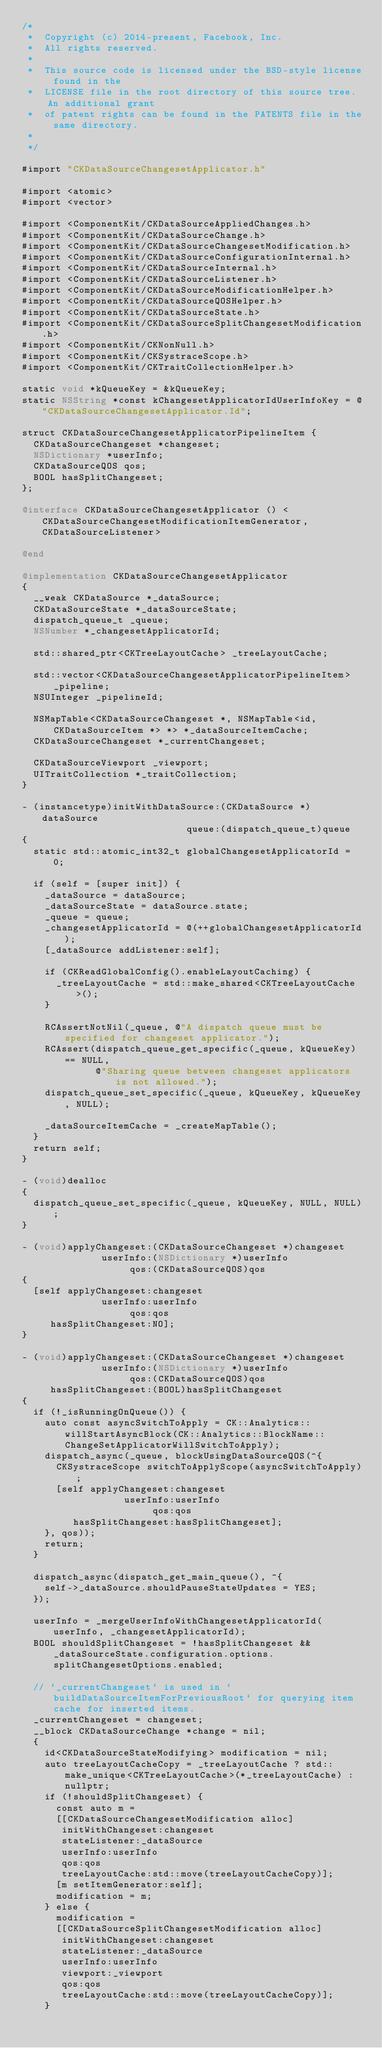Convert code to text. <code><loc_0><loc_0><loc_500><loc_500><_ObjectiveC_>/*
 *  Copyright (c) 2014-present, Facebook, Inc.
 *  All rights reserved.
 *
 *  This source code is licensed under the BSD-style license found in the
 *  LICENSE file in the root directory of this source tree. An additional grant
 *  of patent rights can be found in the PATENTS file in the same directory.
 *
 */

#import "CKDataSourceChangesetApplicator.h"

#import <atomic>
#import <vector>

#import <ComponentKit/CKDataSourceAppliedChanges.h>
#import <ComponentKit/CKDataSourceChange.h>
#import <ComponentKit/CKDataSourceChangesetModification.h>
#import <ComponentKit/CKDataSourceConfigurationInternal.h>
#import <ComponentKit/CKDataSourceInternal.h>
#import <ComponentKit/CKDataSourceListener.h>
#import <ComponentKit/CKDataSourceModificationHelper.h>
#import <ComponentKit/CKDataSourceQOSHelper.h>
#import <ComponentKit/CKDataSourceState.h>
#import <ComponentKit/CKDataSourceSplitChangesetModification.h>
#import <ComponentKit/CKNonNull.h>
#import <ComponentKit/CKSystraceScope.h>
#import <ComponentKit/CKTraitCollectionHelper.h>

static void *kQueueKey = &kQueueKey;
static NSString *const kChangesetApplicatorIdUserInfoKey = @"CKDataSourceChangesetApplicator.Id";

struct CKDataSourceChangesetApplicatorPipelineItem {
  CKDataSourceChangeset *changeset;
  NSDictionary *userInfo;
  CKDataSourceQOS qos;
  BOOL hasSplitChangeset;
};

@interface CKDataSourceChangesetApplicator () <CKDataSourceChangesetModificationItemGenerator, CKDataSourceListener>

@end

@implementation CKDataSourceChangesetApplicator
{
  __weak CKDataSource *_dataSource;
  CKDataSourceState *_dataSourceState;
  dispatch_queue_t _queue;
  NSNumber *_changesetApplicatorId;

  std::shared_ptr<CKTreeLayoutCache> _treeLayoutCache;

  std::vector<CKDataSourceChangesetApplicatorPipelineItem> _pipeline;
  NSUInteger _pipelineId;

  NSMapTable<CKDataSourceChangeset *, NSMapTable<id, CKDataSourceItem *> *> *_dataSourceItemCache;
  CKDataSourceChangeset *_currentChangeset;

  CKDataSourceViewport _viewport;
  UITraitCollection *_traitCollection;
}

- (instancetype)initWithDataSource:(CKDataSource *)dataSource
                             queue:(dispatch_queue_t)queue
{
  static std::atomic_int32_t globalChangesetApplicatorId = 0;

  if (self = [super init]) {
    _dataSource = dataSource;
    _dataSourceState = dataSource.state;
    _queue = queue;
    _changesetApplicatorId = @(++globalChangesetApplicatorId);
    [_dataSource addListener:self];

    if (CKReadGlobalConfig().enableLayoutCaching) {
      _treeLayoutCache = std::make_shared<CKTreeLayoutCache>();
    }

    RCAssertNotNil(_queue, @"A dispatch queue must be specified for changeset applicator.");
    RCAssert(dispatch_queue_get_specific(_queue, kQueueKey) == NULL,
             @"Sharing queue between changeset applicators is not allowed.");
    dispatch_queue_set_specific(_queue, kQueueKey, kQueueKey, NULL);

    _dataSourceItemCache = _createMapTable();
  }
  return self;
}

- (void)dealloc
{
  dispatch_queue_set_specific(_queue, kQueueKey, NULL, NULL);
}

- (void)applyChangeset:(CKDataSourceChangeset *)changeset
              userInfo:(NSDictionary *)userInfo
                   qos:(CKDataSourceQOS)qos
{
  [self applyChangeset:changeset
              userInfo:userInfo
                   qos:qos
     hasSplitChangeset:NO];
}

- (void)applyChangeset:(CKDataSourceChangeset *)changeset
              userInfo:(NSDictionary *)userInfo
                   qos:(CKDataSourceQOS)qos
     hasSplitChangeset:(BOOL)hasSplitChangeset
{
  if (!_isRunningOnQueue()) {
    auto const asyncSwitchToApply = CK::Analytics::willStartAsyncBlock(CK::Analytics::BlockName::ChangeSetApplicatorWillSwitchToApply);
    dispatch_async(_queue, blockUsingDataSourceQOS(^{
      CKSystraceScope switchToApplyScope(asyncSwitchToApply);
      [self applyChangeset:changeset
                  userInfo:userInfo
                       qos:qos
         hasSplitChangeset:hasSplitChangeset];
    }, qos));
    return;
  }

  dispatch_async(dispatch_get_main_queue(), ^{
    self->_dataSource.shouldPauseStateUpdates = YES;
  });

  userInfo = _mergeUserInfoWithChangesetApplicatorId(userInfo, _changesetApplicatorId);
  BOOL shouldSplitChangeset = !hasSplitChangeset && _dataSourceState.configuration.options.splitChangesetOptions.enabled;

  // `_currentChangeset` is used in `buildDataSourceItemForPreviousRoot` for querying item cache for inserted items.
  _currentChangeset = changeset;
  __block CKDataSourceChange *change = nil;
  {
    id<CKDataSourceStateModifying> modification = nil;
    auto treeLayoutCacheCopy = _treeLayoutCache ? std::make_unique<CKTreeLayoutCache>(*_treeLayoutCache) : nullptr;
    if (!shouldSplitChangeset) {
      const auto m =
      [[CKDataSourceChangesetModification alloc]
       initWithChangeset:changeset
       stateListener:_dataSource
       userInfo:userInfo
       qos:qos
       treeLayoutCache:std::move(treeLayoutCacheCopy)];
      [m setItemGenerator:self];
      modification = m;
    } else {
      modification =
      [[CKDataSourceSplitChangesetModification alloc]
       initWithChangeset:changeset
       stateListener:_dataSource
       userInfo:userInfo
       viewport:_viewport
       qos:qos
       treeLayoutCache:std::move(treeLayoutCacheCopy)];
    }</code> 